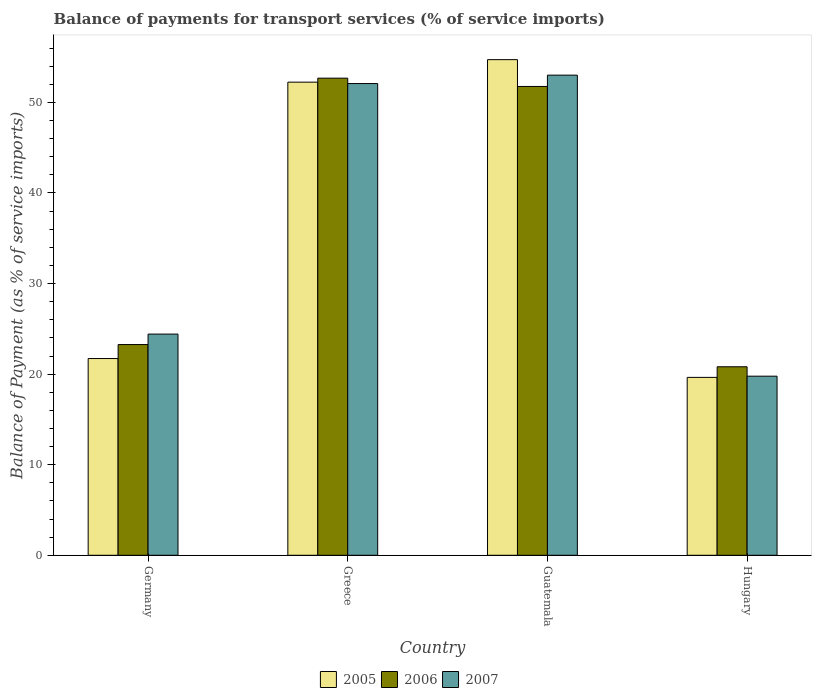Are the number of bars on each tick of the X-axis equal?
Give a very brief answer. Yes. What is the label of the 2nd group of bars from the left?
Ensure brevity in your answer.  Greece. In how many cases, is the number of bars for a given country not equal to the number of legend labels?
Your response must be concise. 0. What is the balance of payments for transport services in 2005 in Greece?
Provide a short and direct response. 52.24. Across all countries, what is the maximum balance of payments for transport services in 2007?
Offer a terse response. 53.01. Across all countries, what is the minimum balance of payments for transport services in 2007?
Offer a very short reply. 19.77. In which country was the balance of payments for transport services in 2005 maximum?
Make the answer very short. Guatemala. In which country was the balance of payments for transport services in 2006 minimum?
Make the answer very short. Hungary. What is the total balance of payments for transport services in 2005 in the graph?
Your response must be concise. 148.31. What is the difference between the balance of payments for transport services in 2006 in Greece and that in Hungary?
Ensure brevity in your answer.  31.86. What is the difference between the balance of payments for transport services in 2006 in Germany and the balance of payments for transport services in 2005 in Guatemala?
Your answer should be very brief. -31.45. What is the average balance of payments for transport services in 2007 per country?
Your response must be concise. 37.32. What is the difference between the balance of payments for transport services of/in 2006 and balance of payments for transport services of/in 2005 in Greece?
Offer a terse response. 0.44. In how many countries, is the balance of payments for transport services in 2005 greater than 50 %?
Provide a succinct answer. 2. What is the ratio of the balance of payments for transport services in 2005 in Germany to that in Greece?
Give a very brief answer. 0.42. Is the balance of payments for transport services in 2006 in Germany less than that in Greece?
Give a very brief answer. Yes. Is the difference between the balance of payments for transport services in 2006 in Greece and Hungary greater than the difference between the balance of payments for transport services in 2005 in Greece and Hungary?
Your answer should be very brief. No. What is the difference between the highest and the second highest balance of payments for transport services in 2007?
Keep it short and to the point. -27.66. What is the difference between the highest and the lowest balance of payments for transport services in 2005?
Keep it short and to the point. 35.08. In how many countries, is the balance of payments for transport services in 2007 greater than the average balance of payments for transport services in 2007 taken over all countries?
Keep it short and to the point. 2. What does the 3rd bar from the left in Guatemala represents?
Ensure brevity in your answer.  2007. What does the 3rd bar from the right in Greece represents?
Make the answer very short. 2005. Are all the bars in the graph horizontal?
Provide a short and direct response. No. What is the difference between two consecutive major ticks on the Y-axis?
Your answer should be very brief. 10. How are the legend labels stacked?
Provide a succinct answer. Horizontal. What is the title of the graph?
Offer a very short reply. Balance of payments for transport services (% of service imports). What is the label or title of the Y-axis?
Give a very brief answer. Balance of Payment (as % of service imports). What is the Balance of Payment (as % of service imports) of 2005 in Germany?
Provide a succinct answer. 21.72. What is the Balance of Payment (as % of service imports) in 2006 in Germany?
Offer a very short reply. 23.26. What is the Balance of Payment (as % of service imports) in 2007 in Germany?
Offer a very short reply. 24.42. What is the Balance of Payment (as % of service imports) of 2005 in Greece?
Your answer should be very brief. 52.24. What is the Balance of Payment (as % of service imports) in 2006 in Greece?
Provide a short and direct response. 52.67. What is the Balance of Payment (as % of service imports) of 2007 in Greece?
Your answer should be very brief. 52.08. What is the Balance of Payment (as % of service imports) in 2005 in Guatemala?
Offer a terse response. 54.72. What is the Balance of Payment (as % of service imports) in 2006 in Guatemala?
Offer a very short reply. 51.76. What is the Balance of Payment (as % of service imports) of 2007 in Guatemala?
Give a very brief answer. 53.01. What is the Balance of Payment (as % of service imports) of 2005 in Hungary?
Make the answer very short. 19.64. What is the Balance of Payment (as % of service imports) of 2006 in Hungary?
Make the answer very short. 20.81. What is the Balance of Payment (as % of service imports) in 2007 in Hungary?
Make the answer very short. 19.77. Across all countries, what is the maximum Balance of Payment (as % of service imports) in 2005?
Your answer should be compact. 54.72. Across all countries, what is the maximum Balance of Payment (as % of service imports) of 2006?
Provide a succinct answer. 52.67. Across all countries, what is the maximum Balance of Payment (as % of service imports) in 2007?
Provide a short and direct response. 53.01. Across all countries, what is the minimum Balance of Payment (as % of service imports) in 2005?
Ensure brevity in your answer.  19.64. Across all countries, what is the minimum Balance of Payment (as % of service imports) in 2006?
Provide a short and direct response. 20.81. Across all countries, what is the minimum Balance of Payment (as % of service imports) of 2007?
Your answer should be very brief. 19.77. What is the total Balance of Payment (as % of service imports) in 2005 in the graph?
Your answer should be compact. 148.31. What is the total Balance of Payment (as % of service imports) of 2006 in the graph?
Keep it short and to the point. 148.51. What is the total Balance of Payment (as % of service imports) in 2007 in the graph?
Offer a terse response. 149.28. What is the difference between the Balance of Payment (as % of service imports) of 2005 in Germany and that in Greece?
Provide a short and direct response. -30.52. What is the difference between the Balance of Payment (as % of service imports) in 2006 in Germany and that in Greece?
Keep it short and to the point. -29.41. What is the difference between the Balance of Payment (as % of service imports) of 2007 in Germany and that in Greece?
Your answer should be very brief. -27.66. What is the difference between the Balance of Payment (as % of service imports) of 2005 in Germany and that in Guatemala?
Give a very brief answer. -33. What is the difference between the Balance of Payment (as % of service imports) of 2006 in Germany and that in Guatemala?
Make the answer very short. -28.5. What is the difference between the Balance of Payment (as % of service imports) of 2007 in Germany and that in Guatemala?
Ensure brevity in your answer.  -28.59. What is the difference between the Balance of Payment (as % of service imports) in 2005 in Germany and that in Hungary?
Ensure brevity in your answer.  2.08. What is the difference between the Balance of Payment (as % of service imports) in 2006 in Germany and that in Hungary?
Ensure brevity in your answer.  2.45. What is the difference between the Balance of Payment (as % of service imports) of 2007 in Germany and that in Hungary?
Ensure brevity in your answer.  4.65. What is the difference between the Balance of Payment (as % of service imports) in 2005 in Greece and that in Guatemala?
Your response must be concise. -2.48. What is the difference between the Balance of Payment (as % of service imports) in 2006 in Greece and that in Guatemala?
Offer a terse response. 0.91. What is the difference between the Balance of Payment (as % of service imports) of 2007 in Greece and that in Guatemala?
Give a very brief answer. -0.93. What is the difference between the Balance of Payment (as % of service imports) of 2005 in Greece and that in Hungary?
Provide a succinct answer. 32.6. What is the difference between the Balance of Payment (as % of service imports) of 2006 in Greece and that in Hungary?
Make the answer very short. 31.86. What is the difference between the Balance of Payment (as % of service imports) in 2007 in Greece and that in Hungary?
Your response must be concise. 32.31. What is the difference between the Balance of Payment (as % of service imports) of 2005 in Guatemala and that in Hungary?
Your response must be concise. 35.08. What is the difference between the Balance of Payment (as % of service imports) in 2006 in Guatemala and that in Hungary?
Make the answer very short. 30.95. What is the difference between the Balance of Payment (as % of service imports) of 2007 in Guatemala and that in Hungary?
Provide a short and direct response. 33.24. What is the difference between the Balance of Payment (as % of service imports) of 2005 in Germany and the Balance of Payment (as % of service imports) of 2006 in Greece?
Keep it short and to the point. -30.95. What is the difference between the Balance of Payment (as % of service imports) in 2005 in Germany and the Balance of Payment (as % of service imports) in 2007 in Greece?
Provide a short and direct response. -30.36. What is the difference between the Balance of Payment (as % of service imports) in 2006 in Germany and the Balance of Payment (as % of service imports) in 2007 in Greece?
Provide a succinct answer. -28.82. What is the difference between the Balance of Payment (as % of service imports) of 2005 in Germany and the Balance of Payment (as % of service imports) of 2006 in Guatemala?
Provide a short and direct response. -30.04. What is the difference between the Balance of Payment (as % of service imports) of 2005 in Germany and the Balance of Payment (as % of service imports) of 2007 in Guatemala?
Offer a terse response. -31.29. What is the difference between the Balance of Payment (as % of service imports) of 2006 in Germany and the Balance of Payment (as % of service imports) of 2007 in Guatemala?
Your answer should be compact. -29.74. What is the difference between the Balance of Payment (as % of service imports) of 2005 in Germany and the Balance of Payment (as % of service imports) of 2006 in Hungary?
Keep it short and to the point. 0.91. What is the difference between the Balance of Payment (as % of service imports) in 2005 in Germany and the Balance of Payment (as % of service imports) in 2007 in Hungary?
Your response must be concise. 1.95. What is the difference between the Balance of Payment (as % of service imports) in 2006 in Germany and the Balance of Payment (as % of service imports) in 2007 in Hungary?
Ensure brevity in your answer.  3.49. What is the difference between the Balance of Payment (as % of service imports) of 2005 in Greece and the Balance of Payment (as % of service imports) of 2006 in Guatemala?
Your answer should be compact. 0.48. What is the difference between the Balance of Payment (as % of service imports) of 2005 in Greece and the Balance of Payment (as % of service imports) of 2007 in Guatemala?
Offer a terse response. -0.77. What is the difference between the Balance of Payment (as % of service imports) in 2006 in Greece and the Balance of Payment (as % of service imports) in 2007 in Guatemala?
Offer a very short reply. -0.33. What is the difference between the Balance of Payment (as % of service imports) of 2005 in Greece and the Balance of Payment (as % of service imports) of 2006 in Hungary?
Offer a very short reply. 31.42. What is the difference between the Balance of Payment (as % of service imports) in 2005 in Greece and the Balance of Payment (as % of service imports) in 2007 in Hungary?
Offer a terse response. 32.46. What is the difference between the Balance of Payment (as % of service imports) of 2006 in Greece and the Balance of Payment (as % of service imports) of 2007 in Hungary?
Give a very brief answer. 32.9. What is the difference between the Balance of Payment (as % of service imports) of 2005 in Guatemala and the Balance of Payment (as % of service imports) of 2006 in Hungary?
Your response must be concise. 33.91. What is the difference between the Balance of Payment (as % of service imports) of 2005 in Guatemala and the Balance of Payment (as % of service imports) of 2007 in Hungary?
Provide a succinct answer. 34.95. What is the difference between the Balance of Payment (as % of service imports) in 2006 in Guatemala and the Balance of Payment (as % of service imports) in 2007 in Hungary?
Offer a terse response. 31.99. What is the average Balance of Payment (as % of service imports) of 2005 per country?
Keep it short and to the point. 37.08. What is the average Balance of Payment (as % of service imports) of 2006 per country?
Your answer should be very brief. 37.13. What is the average Balance of Payment (as % of service imports) of 2007 per country?
Your answer should be compact. 37.32. What is the difference between the Balance of Payment (as % of service imports) of 2005 and Balance of Payment (as % of service imports) of 2006 in Germany?
Make the answer very short. -1.54. What is the difference between the Balance of Payment (as % of service imports) of 2005 and Balance of Payment (as % of service imports) of 2007 in Germany?
Your response must be concise. -2.7. What is the difference between the Balance of Payment (as % of service imports) of 2006 and Balance of Payment (as % of service imports) of 2007 in Germany?
Offer a very short reply. -1.16. What is the difference between the Balance of Payment (as % of service imports) in 2005 and Balance of Payment (as % of service imports) in 2006 in Greece?
Keep it short and to the point. -0.44. What is the difference between the Balance of Payment (as % of service imports) of 2005 and Balance of Payment (as % of service imports) of 2007 in Greece?
Your response must be concise. 0.16. What is the difference between the Balance of Payment (as % of service imports) of 2006 and Balance of Payment (as % of service imports) of 2007 in Greece?
Provide a short and direct response. 0.59. What is the difference between the Balance of Payment (as % of service imports) in 2005 and Balance of Payment (as % of service imports) in 2006 in Guatemala?
Provide a succinct answer. 2.96. What is the difference between the Balance of Payment (as % of service imports) of 2005 and Balance of Payment (as % of service imports) of 2007 in Guatemala?
Provide a succinct answer. 1.71. What is the difference between the Balance of Payment (as % of service imports) of 2006 and Balance of Payment (as % of service imports) of 2007 in Guatemala?
Your answer should be very brief. -1.25. What is the difference between the Balance of Payment (as % of service imports) in 2005 and Balance of Payment (as % of service imports) in 2006 in Hungary?
Provide a short and direct response. -1.17. What is the difference between the Balance of Payment (as % of service imports) of 2005 and Balance of Payment (as % of service imports) of 2007 in Hungary?
Ensure brevity in your answer.  -0.13. What is the difference between the Balance of Payment (as % of service imports) in 2006 and Balance of Payment (as % of service imports) in 2007 in Hungary?
Your answer should be very brief. 1.04. What is the ratio of the Balance of Payment (as % of service imports) of 2005 in Germany to that in Greece?
Ensure brevity in your answer.  0.42. What is the ratio of the Balance of Payment (as % of service imports) of 2006 in Germany to that in Greece?
Ensure brevity in your answer.  0.44. What is the ratio of the Balance of Payment (as % of service imports) of 2007 in Germany to that in Greece?
Your answer should be compact. 0.47. What is the ratio of the Balance of Payment (as % of service imports) in 2005 in Germany to that in Guatemala?
Your answer should be compact. 0.4. What is the ratio of the Balance of Payment (as % of service imports) of 2006 in Germany to that in Guatemala?
Offer a terse response. 0.45. What is the ratio of the Balance of Payment (as % of service imports) of 2007 in Germany to that in Guatemala?
Provide a succinct answer. 0.46. What is the ratio of the Balance of Payment (as % of service imports) of 2005 in Germany to that in Hungary?
Offer a terse response. 1.11. What is the ratio of the Balance of Payment (as % of service imports) in 2006 in Germany to that in Hungary?
Keep it short and to the point. 1.12. What is the ratio of the Balance of Payment (as % of service imports) of 2007 in Germany to that in Hungary?
Ensure brevity in your answer.  1.24. What is the ratio of the Balance of Payment (as % of service imports) of 2005 in Greece to that in Guatemala?
Your response must be concise. 0.95. What is the ratio of the Balance of Payment (as % of service imports) in 2006 in Greece to that in Guatemala?
Provide a succinct answer. 1.02. What is the ratio of the Balance of Payment (as % of service imports) in 2007 in Greece to that in Guatemala?
Offer a very short reply. 0.98. What is the ratio of the Balance of Payment (as % of service imports) of 2005 in Greece to that in Hungary?
Your answer should be very brief. 2.66. What is the ratio of the Balance of Payment (as % of service imports) of 2006 in Greece to that in Hungary?
Give a very brief answer. 2.53. What is the ratio of the Balance of Payment (as % of service imports) in 2007 in Greece to that in Hungary?
Offer a terse response. 2.63. What is the ratio of the Balance of Payment (as % of service imports) of 2005 in Guatemala to that in Hungary?
Provide a succinct answer. 2.79. What is the ratio of the Balance of Payment (as % of service imports) of 2006 in Guatemala to that in Hungary?
Your response must be concise. 2.49. What is the ratio of the Balance of Payment (as % of service imports) in 2007 in Guatemala to that in Hungary?
Make the answer very short. 2.68. What is the difference between the highest and the second highest Balance of Payment (as % of service imports) of 2005?
Provide a short and direct response. 2.48. What is the difference between the highest and the second highest Balance of Payment (as % of service imports) in 2006?
Offer a terse response. 0.91. What is the difference between the highest and the second highest Balance of Payment (as % of service imports) of 2007?
Make the answer very short. 0.93. What is the difference between the highest and the lowest Balance of Payment (as % of service imports) in 2005?
Ensure brevity in your answer.  35.08. What is the difference between the highest and the lowest Balance of Payment (as % of service imports) of 2006?
Your answer should be compact. 31.86. What is the difference between the highest and the lowest Balance of Payment (as % of service imports) in 2007?
Your answer should be very brief. 33.24. 